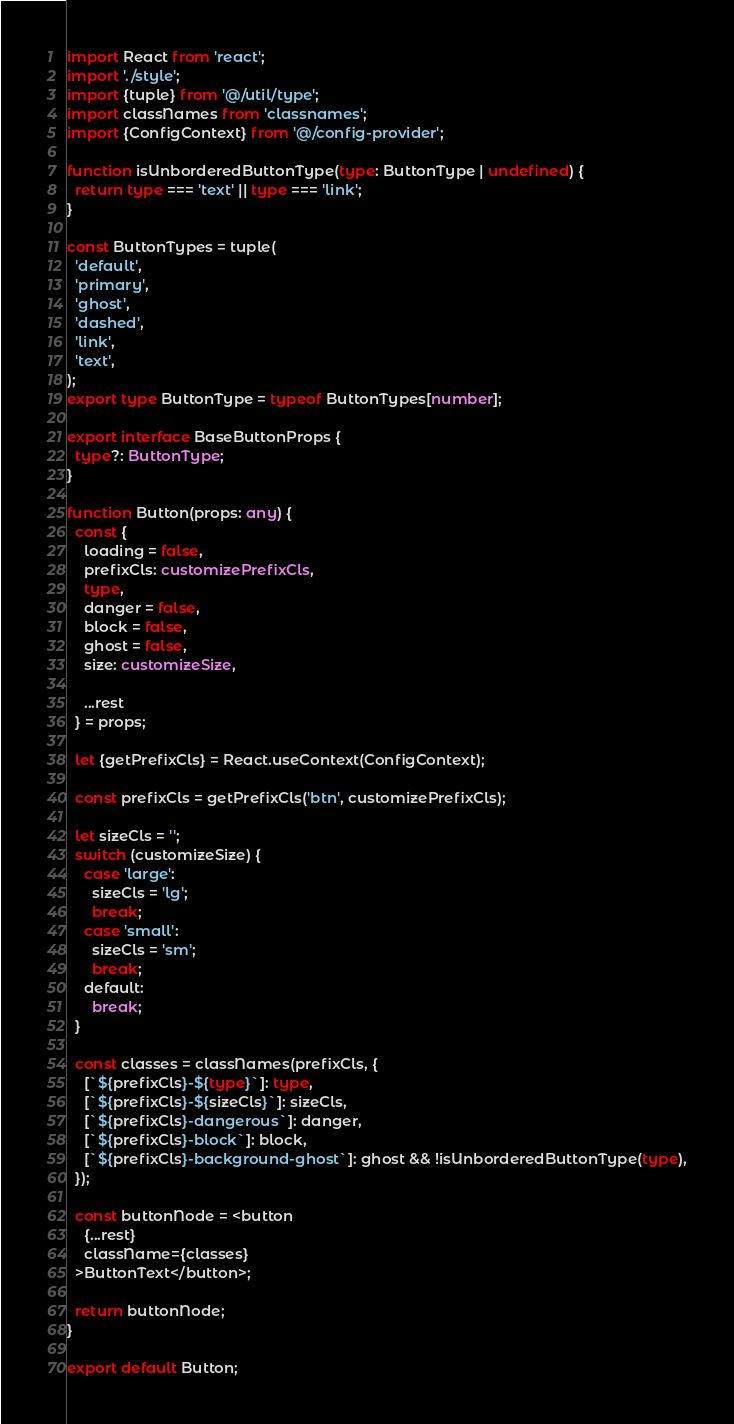<code> <loc_0><loc_0><loc_500><loc_500><_TypeScript_>import React from 'react';
import './style';
import {tuple} from '@/util/type';
import classNames from 'classnames';
import {ConfigContext} from '@/config-provider';

function isUnborderedButtonType(type: ButtonType | undefined) {
  return type === 'text' || type === 'link';
}

const ButtonTypes = tuple(
  'default',
  'primary',
  'ghost',
  'dashed',
  'link',
  'text',
);
export type ButtonType = typeof ButtonTypes[number];

export interface BaseButtonProps {
  type?: ButtonType;
}

function Button(props: any) {
  const {
    loading = false,
    prefixCls: customizePrefixCls,
    type,
    danger = false,
    block = false,
    ghost = false,
    size: customizeSize,

    ...rest
  } = props;

  let {getPrefixCls} = React.useContext(ConfigContext);

  const prefixCls = getPrefixCls('btn', customizePrefixCls);

  let sizeCls = '';
  switch (customizeSize) {
    case 'large':
      sizeCls = 'lg';
      break;
    case 'small':
      sizeCls = 'sm';
      break;
    default:
      break;
  }

  const classes = classNames(prefixCls, {
    [`${prefixCls}-${type}`]: type,
    [`${prefixCls}-${sizeCls}`]: sizeCls,
    [`${prefixCls}-dangerous`]: danger,
    [`${prefixCls}-block`]: block,
    [`${prefixCls}-background-ghost`]: ghost && !isUnborderedButtonType(type),
  });

  const buttonNode = <button
    {...rest}
    className={classes}
  >ButtonText</button>;

  return buttonNode;
}

export default Button;
</code> 